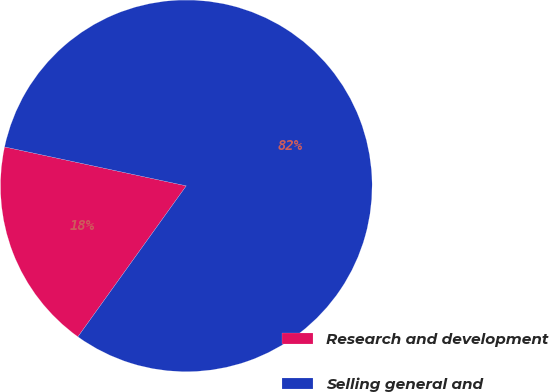Convert chart. <chart><loc_0><loc_0><loc_500><loc_500><pie_chart><fcel>Research and development<fcel>Selling general and<nl><fcel>18.45%<fcel>81.55%<nl></chart> 